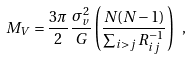Convert formula to latex. <formula><loc_0><loc_0><loc_500><loc_500>M _ { V } = \frac { 3 \pi } { 2 } \frac { \sigma ^ { 2 } _ { v } } { G } \left ( \frac { N ( N - 1 ) } { \sum _ { i > j } R ^ { - 1 } _ { i j } } \right ) \ ,</formula> 